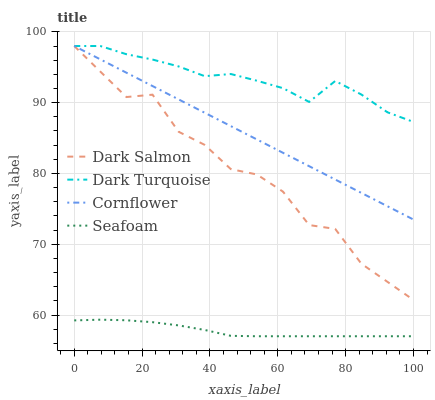Does Seafoam have the minimum area under the curve?
Answer yes or no. Yes. Does Dark Turquoise have the maximum area under the curve?
Answer yes or no. Yes. Does Dark Salmon have the minimum area under the curve?
Answer yes or no. No. Does Dark Salmon have the maximum area under the curve?
Answer yes or no. No. Is Cornflower the smoothest?
Answer yes or no. Yes. Is Dark Salmon the roughest?
Answer yes or no. Yes. Is Seafoam the smoothest?
Answer yes or no. No. Is Seafoam the roughest?
Answer yes or no. No. Does Seafoam have the lowest value?
Answer yes or no. Yes. Does Dark Salmon have the lowest value?
Answer yes or no. No. Does Cornflower have the highest value?
Answer yes or no. Yes. Does Seafoam have the highest value?
Answer yes or no. No. Is Seafoam less than Dark Turquoise?
Answer yes or no. Yes. Is Dark Turquoise greater than Seafoam?
Answer yes or no. Yes. Does Dark Turquoise intersect Cornflower?
Answer yes or no. Yes. Is Dark Turquoise less than Cornflower?
Answer yes or no. No. Is Dark Turquoise greater than Cornflower?
Answer yes or no. No. Does Seafoam intersect Dark Turquoise?
Answer yes or no. No. 